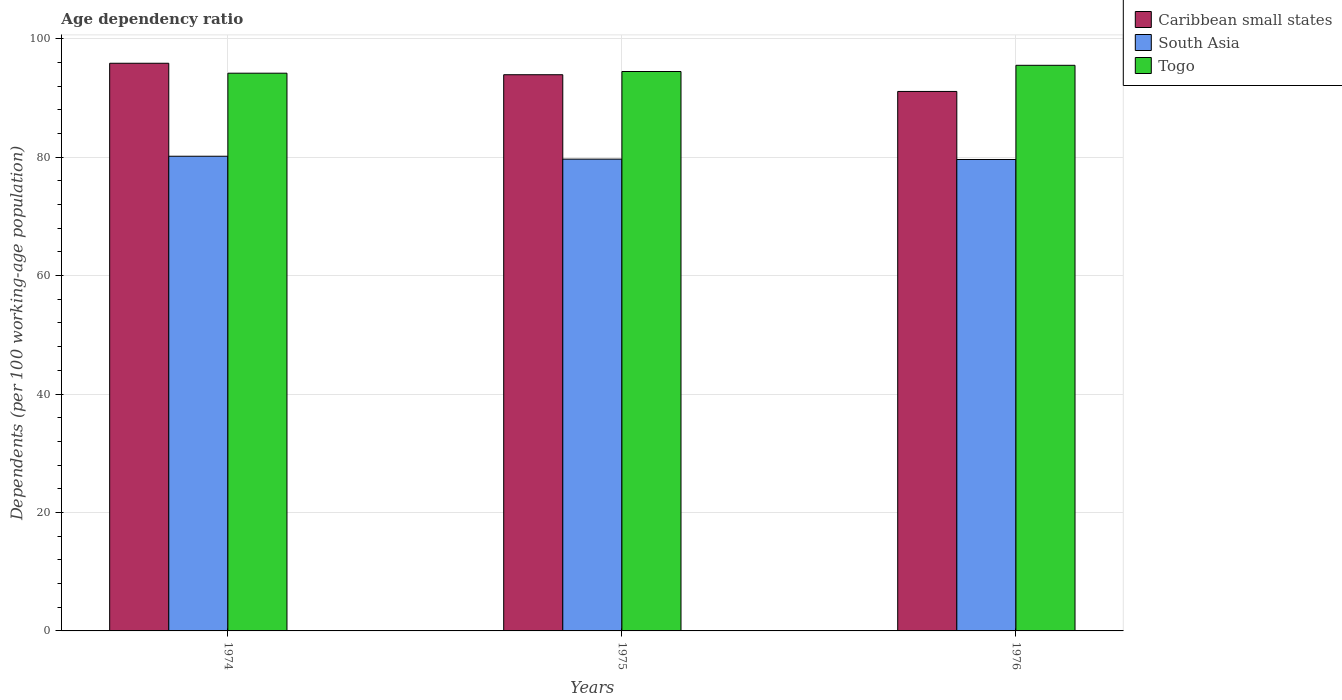What is the label of the 3rd group of bars from the left?
Your answer should be very brief. 1976. In how many cases, is the number of bars for a given year not equal to the number of legend labels?
Make the answer very short. 0. What is the age dependency ratio in in South Asia in 1974?
Keep it short and to the point. 80.15. Across all years, what is the maximum age dependency ratio in in South Asia?
Your response must be concise. 80.15. Across all years, what is the minimum age dependency ratio in in Togo?
Make the answer very short. 94.17. In which year was the age dependency ratio in in South Asia maximum?
Give a very brief answer. 1974. In which year was the age dependency ratio in in Caribbean small states minimum?
Provide a succinct answer. 1976. What is the total age dependency ratio in in Togo in the graph?
Provide a succinct answer. 284.13. What is the difference between the age dependency ratio in in Caribbean small states in 1975 and that in 1976?
Your response must be concise. 2.82. What is the difference between the age dependency ratio in in South Asia in 1976 and the age dependency ratio in in Caribbean small states in 1974?
Your answer should be compact. -16.25. What is the average age dependency ratio in in Togo per year?
Offer a terse response. 94.71. In the year 1976, what is the difference between the age dependency ratio in in South Asia and age dependency ratio in in Caribbean small states?
Give a very brief answer. -11.49. In how many years, is the age dependency ratio in in Caribbean small states greater than 60 %?
Provide a succinct answer. 3. What is the ratio of the age dependency ratio in in South Asia in 1975 to that in 1976?
Make the answer very short. 1. Is the age dependency ratio in in Caribbean small states in 1975 less than that in 1976?
Make the answer very short. No. Is the difference between the age dependency ratio in in South Asia in 1974 and 1976 greater than the difference between the age dependency ratio in in Caribbean small states in 1974 and 1976?
Your response must be concise. No. What is the difference between the highest and the second highest age dependency ratio in in South Asia?
Your response must be concise. 0.49. What is the difference between the highest and the lowest age dependency ratio in in South Asia?
Give a very brief answer. 0.55. In how many years, is the age dependency ratio in in South Asia greater than the average age dependency ratio in in South Asia taken over all years?
Provide a succinct answer. 1. What does the 1st bar from the left in 1976 represents?
Make the answer very short. Caribbean small states. What does the 1st bar from the right in 1974 represents?
Provide a short and direct response. Togo. Is it the case that in every year, the sum of the age dependency ratio in in South Asia and age dependency ratio in in Caribbean small states is greater than the age dependency ratio in in Togo?
Offer a very short reply. Yes. How many bars are there?
Offer a terse response. 9. What is the difference between two consecutive major ticks on the Y-axis?
Ensure brevity in your answer.  20. How are the legend labels stacked?
Give a very brief answer. Vertical. What is the title of the graph?
Your response must be concise. Age dependency ratio. Does "Fiji" appear as one of the legend labels in the graph?
Your answer should be compact. No. What is the label or title of the X-axis?
Your answer should be compact. Years. What is the label or title of the Y-axis?
Ensure brevity in your answer.  Dependents (per 100 working-age population). What is the Dependents (per 100 working-age population) in Caribbean small states in 1974?
Your answer should be very brief. 95.85. What is the Dependents (per 100 working-age population) in South Asia in 1974?
Offer a very short reply. 80.15. What is the Dependents (per 100 working-age population) in Togo in 1974?
Offer a very short reply. 94.17. What is the Dependents (per 100 working-age population) of Caribbean small states in 1975?
Ensure brevity in your answer.  93.91. What is the Dependents (per 100 working-age population) in South Asia in 1975?
Your answer should be compact. 79.66. What is the Dependents (per 100 working-age population) in Togo in 1975?
Your response must be concise. 94.46. What is the Dependents (per 100 working-age population) of Caribbean small states in 1976?
Make the answer very short. 91.09. What is the Dependents (per 100 working-age population) in South Asia in 1976?
Offer a very short reply. 79.6. What is the Dependents (per 100 working-age population) in Togo in 1976?
Give a very brief answer. 95.5. Across all years, what is the maximum Dependents (per 100 working-age population) of Caribbean small states?
Make the answer very short. 95.85. Across all years, what is the maximum Dependents (per 100 working-age population) in South Asia?
Offer a very short reply. 80.15. Across all years, what is the maximum Dependents (per 100 working-age population) in Togo?
Offer a terse response. 95.5. Across all years, what is the minimum Dependents (per 100 working-age population) in Caribbean small states?
Make the answer very short. 91.09. Across all years, what is the minimum Dependents (per 100 working-age population) of South Asia?
Your response must be concise. 79.6. Across all years, what is the minimum Dependents (per 100 working-age population) in Togo?
Keep it short and to the point. 94.17. What is the total Dependents (per 100 working-age population) in Caribbean small states in the graph?
Provide a succinct answer. 280.85. What is the total Dependents (per 100 working-age population) of South Asia in the graph?
Provide a short and direct response. 239.41. What is the total Dependents (per 100 working-age population) in Togo in the graph?
Give a very brief answer. 284.13. What is the difference between the Dependents (per 100 working-age population) of Caribbean small states in 1974 and that in 1975?
Make the answer very short. 1.94. What is the difference between the Dependents (per 100 working-age population) of South Asia in 1974 and that in 1975?
Ensure brevity in your answer.  0.49. What is the difference between the Dependents (per 100 working-age population) of Togo in 1974 and that in 1975?
Provide a succinct answer. -0.29. What is the difference between the Dependents (per 100 working-age population) of Caribbean small states in 1974 and that in 1976?
Your response must be concise. 4.76. What is the difference between the Dependents (per 100 working-age population) in South Asia in 1974 and that in 1976?
Provide a succinct answer. 0.55. What is the difference between the Dependents (per 100 working-age population) of Togo in 1974 and that in 1976?
Provide a succinct answer. -1.33. What is the difference between the Dependents (per 100 working-age population) in Caribbean small states in 1975 and that in 1976?
Keep it short and to the point. 2.82. What is the difference between the Dependents (per 100 working-age population) in South Asia in 1975 and that in 1976?
Your response must be concise. 0.06. What is the difference between the Dependents (per 100 working-age population) in Togo in 1975 and that in 1976?
Provide a short and direct response. -1.05. What is the difference between the Dependents (per 100 working-age population) in Caribbean small states in 1974 and the Dependents (per 100 working-age population) in South Asia in 1975?
Give a very brief answer. 16.19. What is the difference between the Dependents (per 100 working-age population) in Caribbean small states in 1974 and the Dependents (per 100 working-age population) in Togo in 1975?
Keep it short and to the point. 1.39. What is the difference between the Dependents (per 100 working-age population) in South Asia in 1974 and the Dependents (per 100 working-age population) in Togo in 1975?
Make the answer very short. -14.31. What is the difference between the Dependents (per 100 working-age population) in Caribbean small states in 1974 and the Dependents (per 100 working-age population) in South Asia in 1976?
Ensure brevity in your answer.  16.25. What is the difference between the Dependents (per 100 working-age population) in Caribbean small states in 1974 and the Dependents (per 100 working-age population) in Togo in 1976?
Your answer should be very brief. 0.35. What is the difference between the Dependents (per 100 working-age population) in South Asia in 1974 and the Dependents (per 100 working-age population) in Togo in 1976?
Your answer should be compact. -15.36. What is the difference between the Dependents (per 100 working-age population) in Caribbean small states in 1975 and the Dependents (per 100 working-age population) in South Asia in 1976?
Your answer should be very brief. 14.31. What is the difference between the Dependents (per 100 working-age population) of Caribbean small states in 1975 and the Dependents (per 100 working-age population) of Togo in 1976?
Your answer should be compact. -1.59. What is the difference between the Dependents (per 100 working-age population) in South Asia in 1975 and the Dependents (per 100 working-age population) in Togo in 1976?
Offer a terse response. -15.84. What is the average Dependents (per 100 working-age population) of Caribbean small states per year?
Your answer should be very brief. 93.62. What is the average Dependents (per 100 working-age population) of South Asia per year?
Keep it short and to the point. 79.8. What is the average Dependents (per 100 working-age population) in Togo per year?
Your answer should be very brief. 94.71. In the year 1974, what is the difference between the Dependents (per 100 working-age population) of Caribbean small states and Dependents (per 100 working-age population) of South Asia?
Your response must be concise. 15.7. In the year 1974, what is the difference between the Dependents (per 100 working-age population) in Caribbean small states and Dependents (per 100 working-age population) in Togo?
Your answer should be compact. 1.68. In the year 1974, what is the difference between the Dependents (per 100 working-age population) in South Asia and Dependents (per 100 working-age population) in Togo?
Your response must be concise. -14.02. In the year 1975, what is the difference between the Dependents (per 100 working-age population) of Caribbean small states and Dependents (per 100 working-age population) of South Asia?
Provide a succinct answer. 14.25. In the year 1975, what is the difference between the Dependents (per 100 working-age population) of Caribbean small states and Dependents (per 100 working-age population) of Togo?
Offer a terse response. -0.55. In the year 1975, what is the difference between the Dependents (per 100 working-age population) in South Asia and Dependents (per 100 working-age population) in Togo?
Keep it short and to the point. -14.8. In the year 1976, what is the difference between the Dependents (per 100 working-age population) in Caribbean small states and Dependents (per 100 working-age population) in South Asia?
Offer a terse response. 11.49. In the year 1976, what is the difference between the Dependents (per 100 working-age population) of Caribbean small states and Dependents (per 100 working-age population) of Togo?
Provide a succinct answer. -4.41. In the year 1976, what is the difference between the Dependents (per 100 working-age population) in South Asia and Dependents (per 100 working-age population) in Togo?
Provide a succinct answer. -15.9. What is the ratio of the Dependents (per 100 working-age population) of Caribbean small states in 1974 to that in 1975?
Your response must be concise. 1.02. What is the ratio of the Dependents (per 100 working-age population) of Togo in 1974 to that in 1975?
Give a very brief answer. 1. What is the ratio of the Dependents (per 100 working-age population) of Caribbean small states in 1974 to that in 1976?
Give a very brief answer. 1.05. What is the ratio of the Dependents (per 100 working-age population) in Caribbean small states in 1975 to that in 1976?
Ensure brevity in your answer.  1.03. What is the ratio of the Dependents (per 100 working-age population) in Togo in 1975 to that in 1976?
Make the answer very short. 0.99. What is the difference between the highest and the second highest Dependents (per 100 working-age population) in Caribbean small states?
Offer a terse response. 1.94. What is the difference between the highest and the second highest Dependents (per 100 working-age population) in South Asia?
Your response must be concise. 0.49. What is the difference between the highest and the second highest Dependents (per 100 working-age population) in Togo?
Your answer should be very brief. 1.05. What is the difference between the highest and the lowest Dependents (per 100 working-age population) of Caribbean small states?
Keep it short and to the point. 4.76. What is the difference between the highest and the lowest Dependents (per 100 working-age population) in South Asia?
Your response must be concise. 0.55. What is the difference between the highest and the lowest Dependents (per 100 working-age population) of Togo?
Provide a succinct answer. 1.33. 